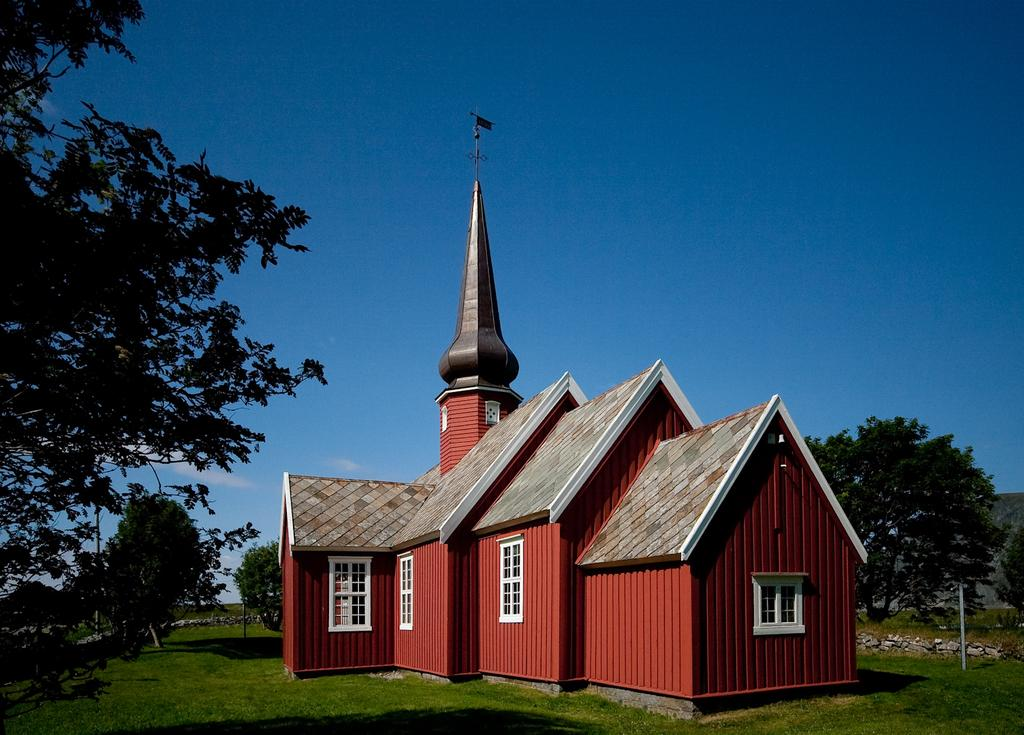What type of structure is visible in the image? There is a house in the image. What type of vegetation can be seen in the image? There are trees and grass in the image. What is visible at the top of the image? The sky is visible at the top of the image. Can you see a goat grazing on the boundary of the house in the image? There is no goat or boundary visible in the image; it only features a house, trees, grass, and the sky. Is there a boat docked near the house in the image? There is no boat present in the image; it only features a house, trees, grass, and the sky. 